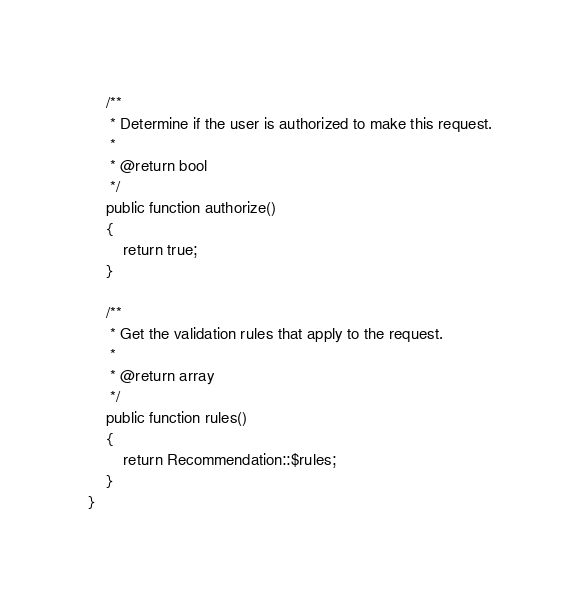<code> <loc_0><loc_0><loc_500><loc_500><_PHP_>    /**
     * Determine if the user is authorized to make this request.
     *
     * @return bool
     */
    public function authorize()
    {
        return true;
    }

    /**
     * Get the validation rules that apply to the request.
     *
     * @return array
     */
    public function rules()
    {
        return Recommendation::$rules;
    }
}
</code> 